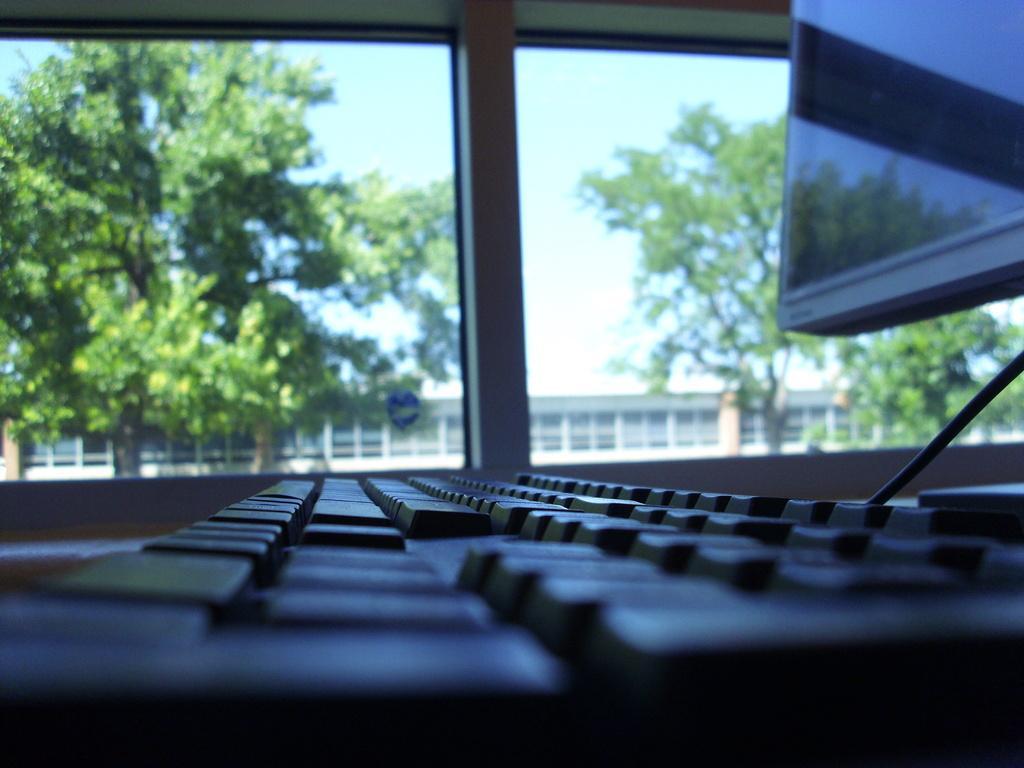Could you give a brief overview of what you see in this image? In this image we can see a keypad and a monitor. On the backside we can see a window, trees, house and the sky. 